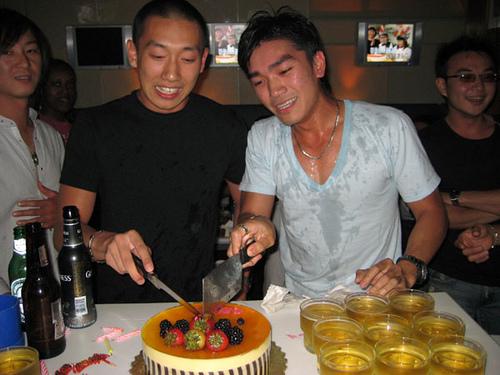Is the guy with the glasses right handed?
Answer briefly. Yes. Are there fruits on the cake?
Short answer required. Yes. What color is the cake?
Write a very short answer. Orange. Is that a birthday cake?
Write a very short answer. Yes. What is in the cups?
Short answer required. Beer. 